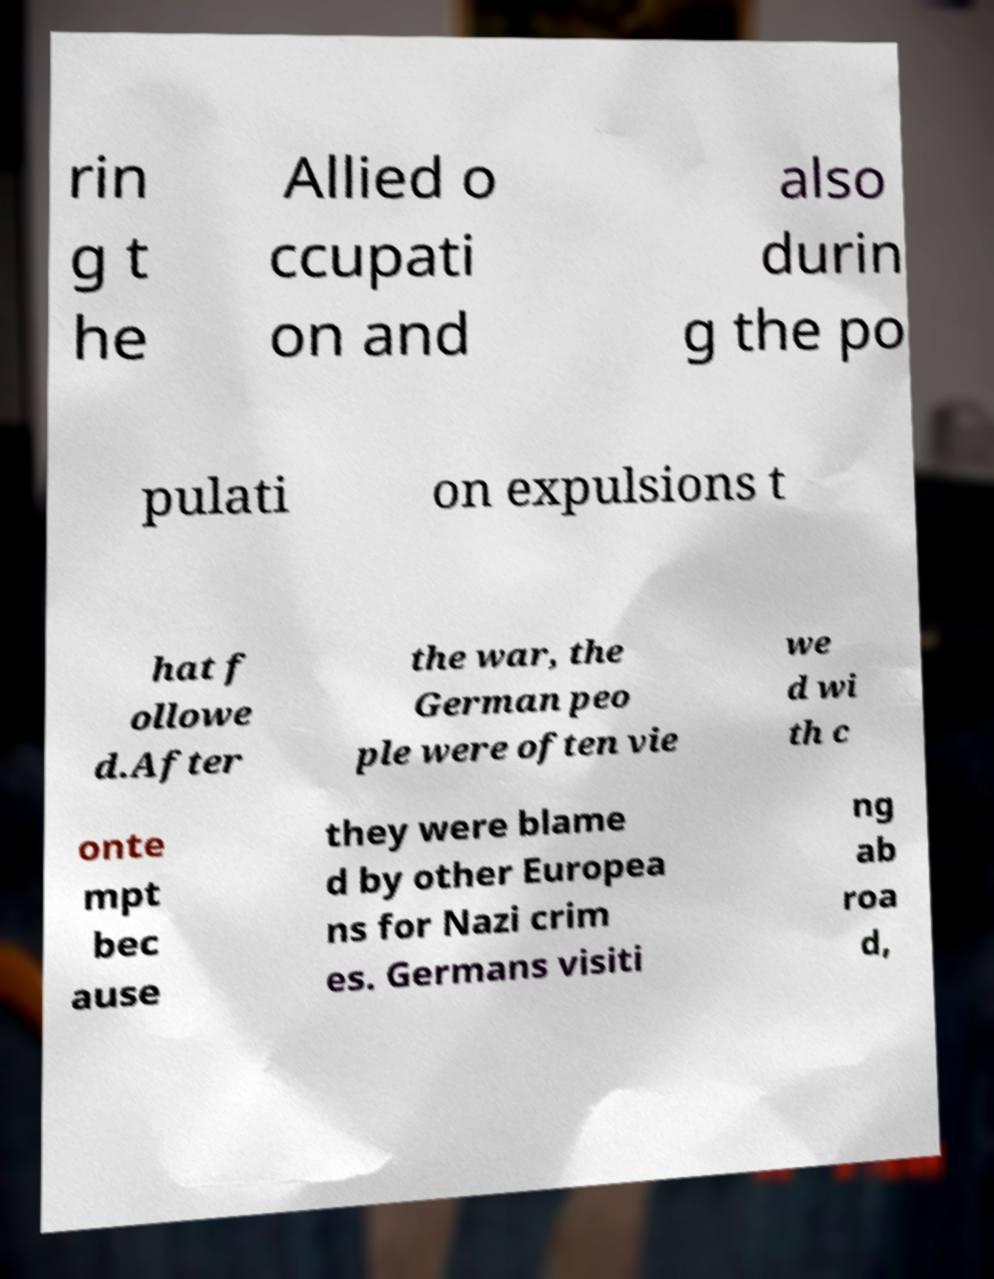Can you accurately transcribe the text from the provided image for me? rin g t he Allied o ccupati on and also durin g the po pulati on expulsions t hat f ollowe d.After the war, the German peo ple were often vie we d wi th c onte mpt bec ause they were blame d by other Europea ns for Nazi crim es. Germans visiti ng ab roa d, 